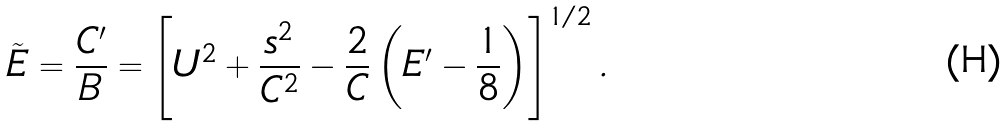Convert formula to latex. <formula><loc_0><loc_0><loc_500><loc_500>\tilde { E } = \frac { C ^ { \prime } } { B } = \left [ U ^ { 2 } + \frac { s ^ { 2 } } { C ^ { 2 } } - \frac { 2 } { C } \left ( E ^ { \prime } - \frac { 1 } { 8 } \right ) \right ] ^ { 1 / 2 } .</formula> 